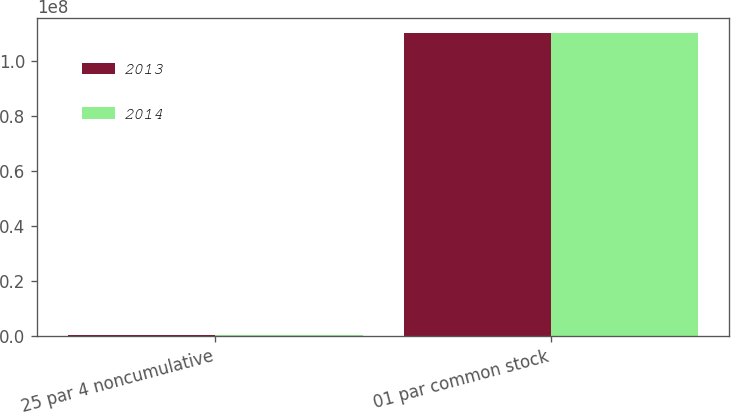Convert chart. <chart><loc_0><loc_0><loc_500><loc_500><stacked_bar_chart><ecel><fcel>25 par 4 noncumulative<fcel>01 par common stock<nl><fcel>2013<fcel>242170<fcel>1.10392e+08<nl><fcel>2014<fcel>242170<fcel>1.10229e+08<nl></chart> 